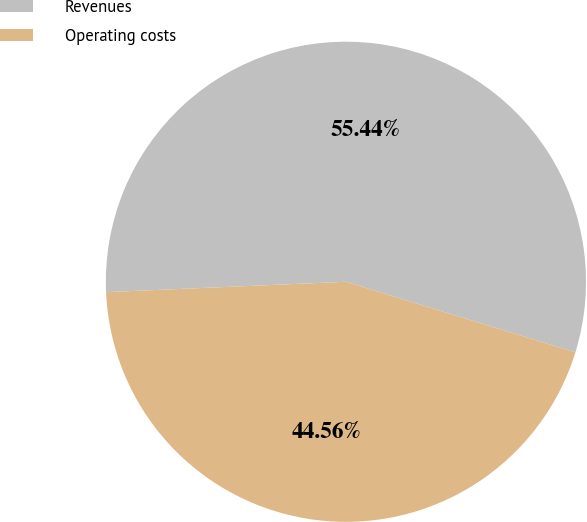<chart> <loc_0><loc_0><loc_500><loc_500><pie_chart><fcel>Revenues<fcel>Operating costs<nl><fcel>55.44%<fcel>44.56%<nl></chart> 